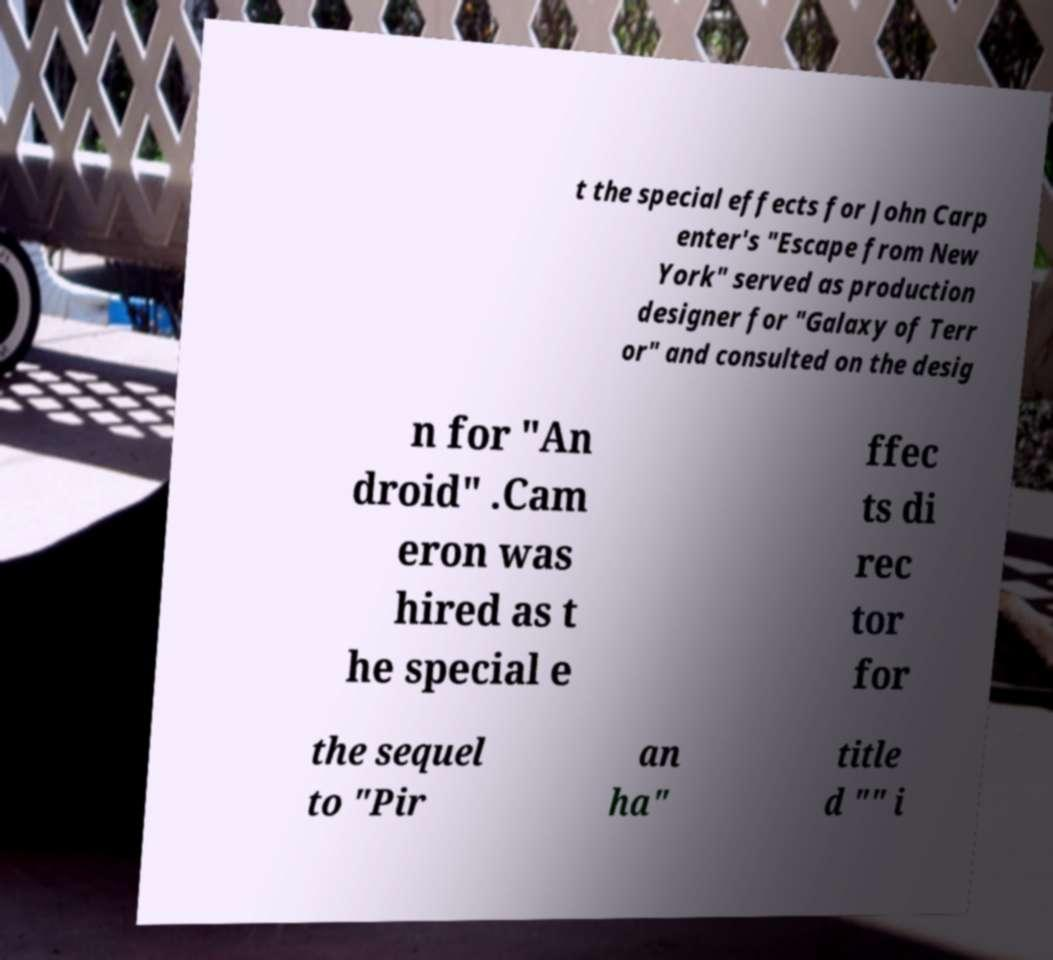Can you read and provide the text displayed in the image?This photo seems to have some interesting text. Can you extract and type it out for me? t the special effects for John Carp enter's "Escape from New York" served as production designer for "Galaxy of Terr or" and consulted on the desig n for "An droid" .Cam eron was hired as t he special e ffec ts di rec tor for the sequel to "Pir an ha" title d "" i 